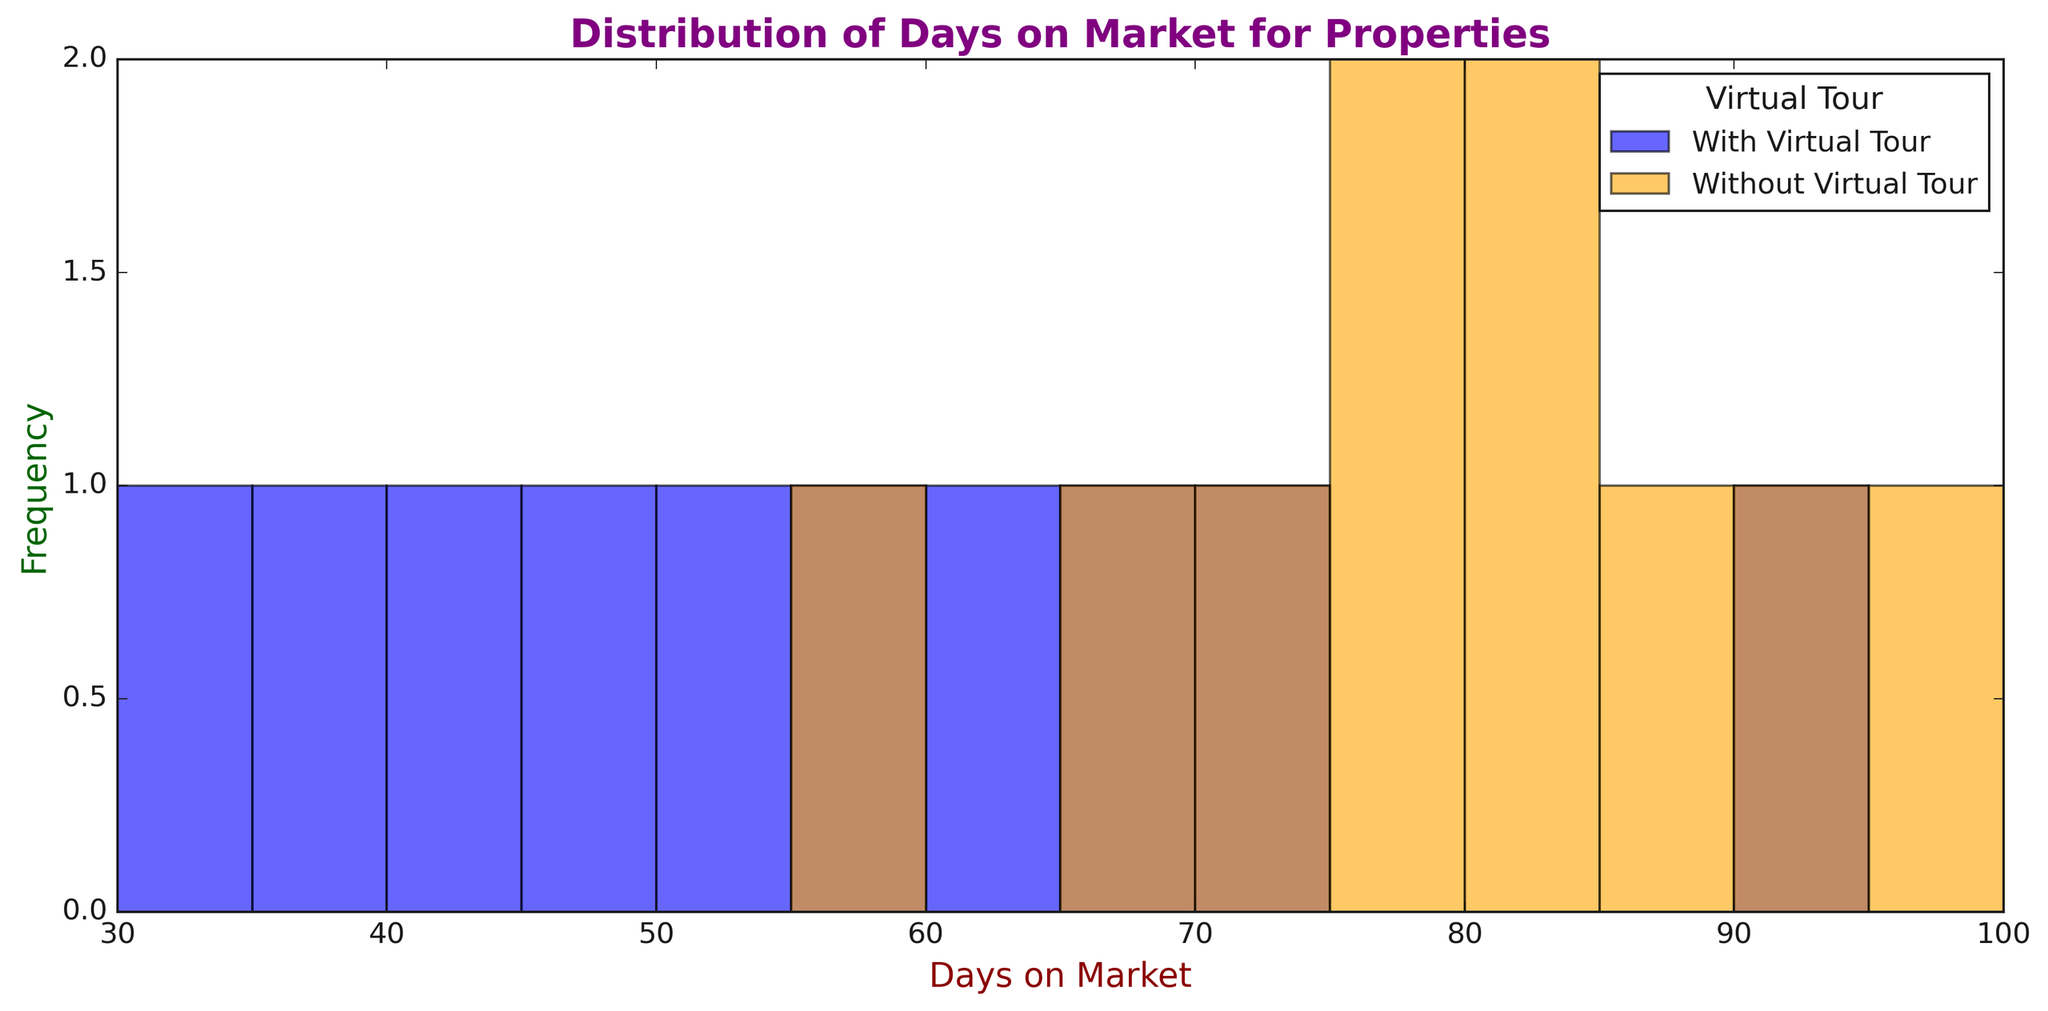What is the average number of days on the market for properties with a virtual tour? To determine the average, sum all the days on market for properties with a virtual tour and divide by the number of such properties. The values are 45, 62, 37, 70, 50, 55, 30, 90, 40, 65. Sum = 544. Number of properties = 10. Average = 544 / 10 = 54.4
Answer: 54.4 Which category of properties (with or without virtual tours) tends to stay on the market longer? Compare the distributions shown in the histograms. Properties without virtual tours generally have more days on market, evidenced by higher frequencies at larger day ranges (70-100) compared to properties with virtual tours.
Answer: Without virtual tours How many properties without a virtual tour stayed on the market for more than 80 days? Count the number of bars in the histogram for "Without Virtual Tour" that are positioned greater than 80 days. You see a total of 5 properties (80, 95, 83, 85, 93).
Answer: 5 What is the difference between the maximum number of days on the market for properties with and without virtual tours? Identify the highest value in each category. For properties with virtual tours, the maximum is 90 days. For properties without virtual tours, the maximum is 95 days. Difference = 95 - 90 = 5.
Answer: 5 Which group has a higher frequency of properties listed for 50 to 60 days? Look at the histogram bars for the 50-60 day range. Count the bars for both categories. Properties with virtual tours have 2 bars (50, 55) while properties without virtual tours have no bars in this range.
Answer: With virtual tours What is the median number of days on market for properties without a virtual tour? Arrange the days on market for properties without virtual tours in ascending order: 58, 67, 72, 75, 78, 80, 83, 85, 93, 95. The median is the 5th value in this ordered list since there are 10 values. Median = (78 + 80) / 2 = 79.
Answer: 79 Which visual feature is used to indicate properties with and without virtual tours in the histogram? Look at the legend and observe the colors of the bars. Properties with virtual tours are shown in blue, and properties without virtual tours are shown in orange.
Answer: Color What is the range of days on the market for properties without virtual tours? Identify the minimum and maximum values for properties without virtual tours. Minimum value = 58. Maximum value = 95. Range = 95 - 58 = 37.
Answer: 37 